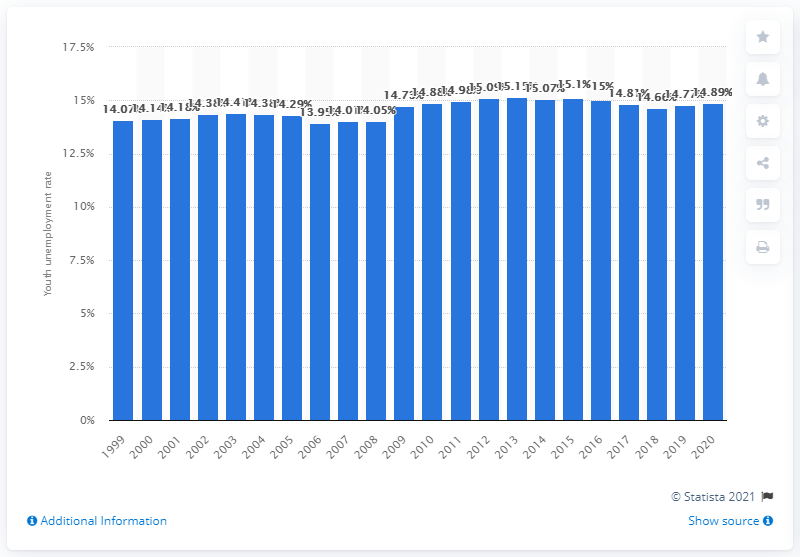Draw attention to some important aspects in this diagram. In 2020, the youth unemployment rate in Mauritania was 14.89%. 